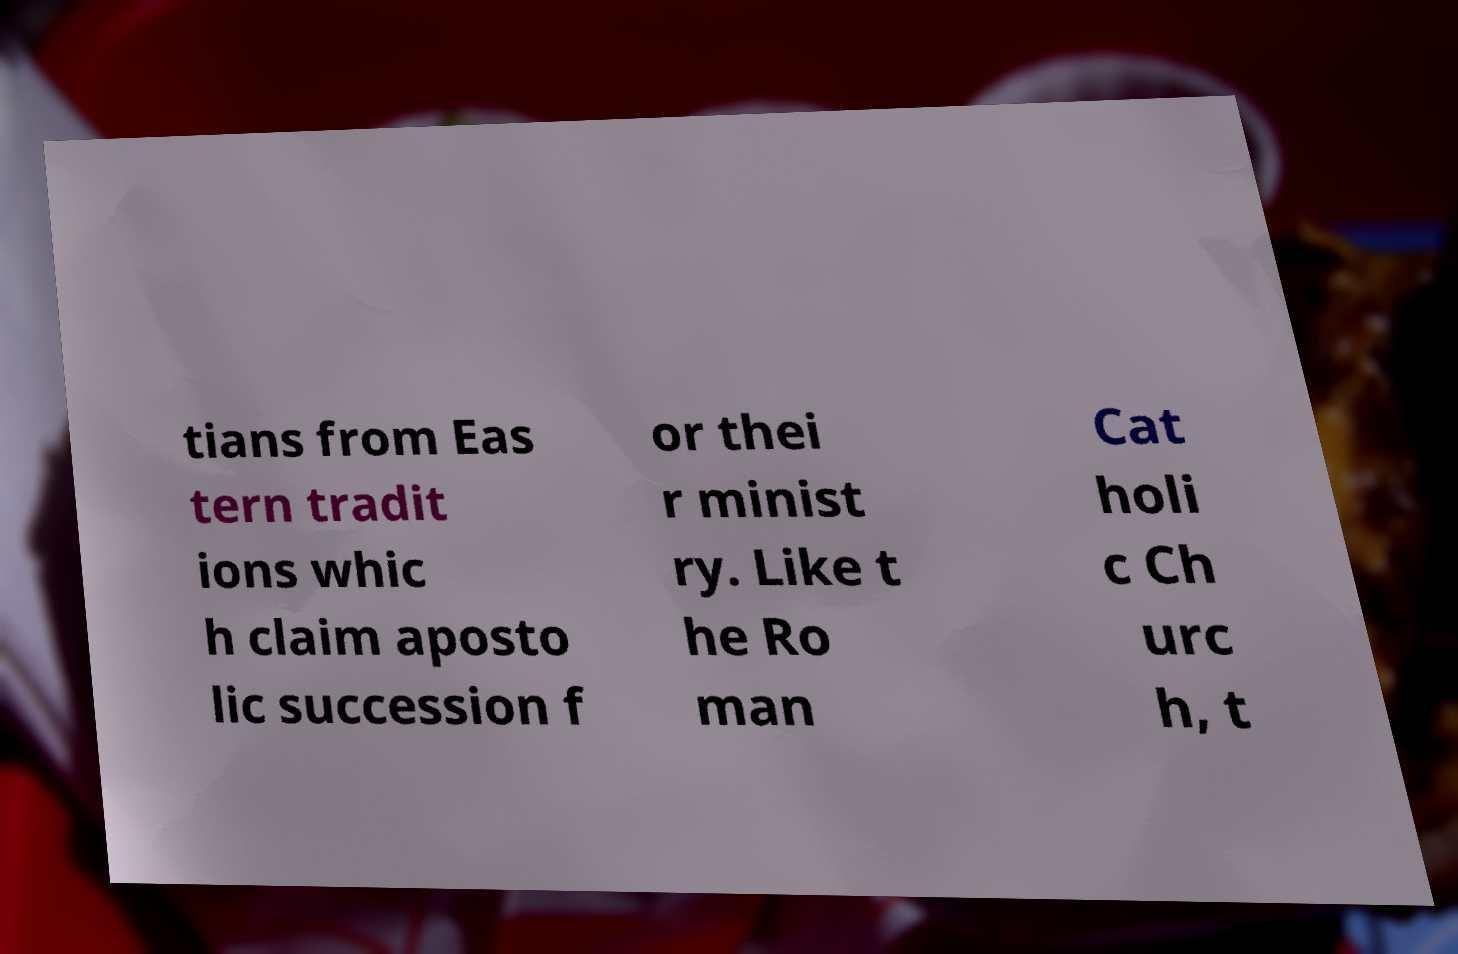I need the written content from this picture converted into text. Can you do that? tians from Eas tern tradit ions whic h claim aposto lic succession f or thei r minist ry. Like t he Ro man Cat holi c Ch urc h, t 